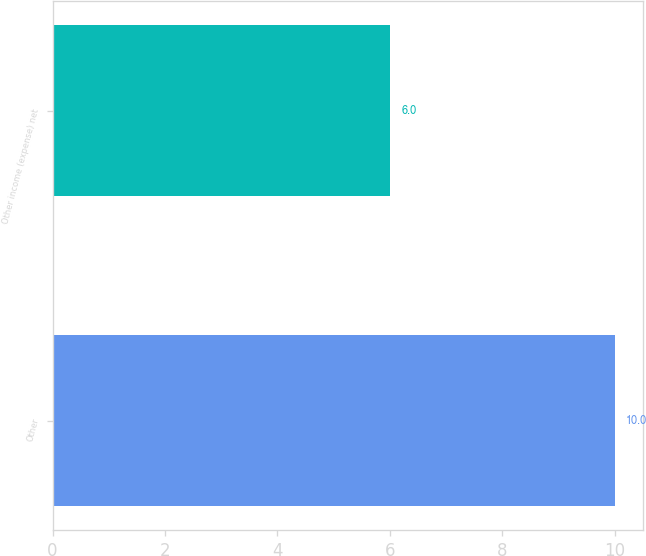Convert chart to OTSL. <chart><loc_0><loc_0><loc_500><loc_500><bar_chart><fcel>Other<fcel>Other income (expense) net<nl><fcel>10<fcel>6<nl></chart> 